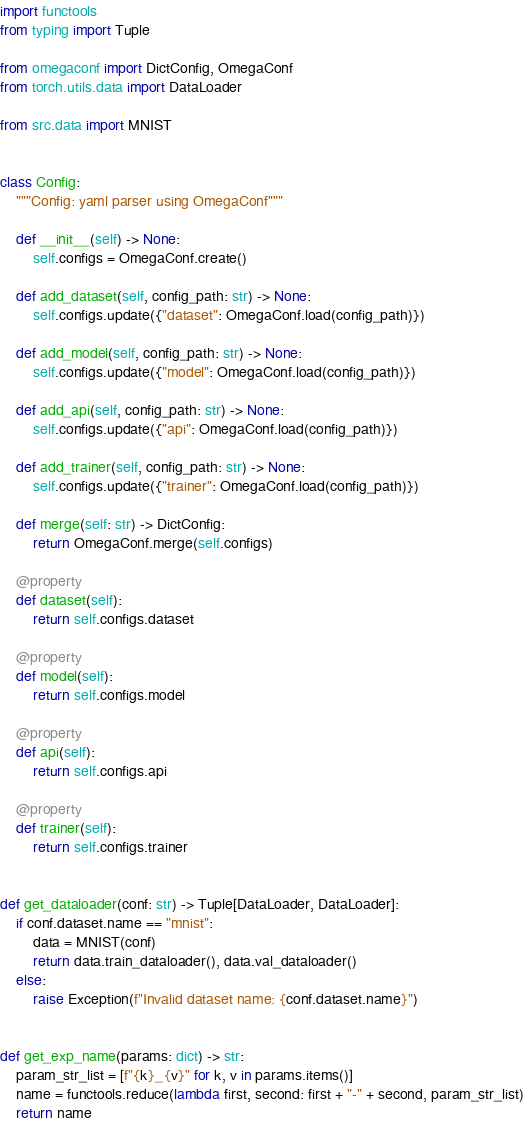Convert code to text. <code><loc_0><loc_0><loc_500><loc_500><_Python_>import functools
from typing import Tuple

from omegaconf import DictConfig, OmegaConf
from torch.utils.data import DataLoader

from src.data import MNIST


class Config:
    """Config: yaml parser using OmegaConf"""

    def __init__(self) -> None:
        self.configs = OmegaConf.create()

    def add_dataset(self, config_path: str) -> None:
        self.configs.update({"dataset": OmegaConf.load(config_path)})

    def add_model(self, config_path: str) -> None:
        self.configs.update({"model": OmegaConf.load(config_path)})

    def add_api(self, config_path: str) -> None:
        self.configs.update({"api": OmegaConf.load(config_path)})

    def add_trainer(self, config_path: str) -> None:
        self.configs.update({"trainer": OmegaConf.load(config_path)})

    def merge(self: str) -> DictConfig:
        return OmegaConf.merge(self.configs)

    @property
    def dataset(self):
        return self.configs.dataset

    @property
    def model(self):
        return self.configs.model

    @property
    def api(self):
        return self.configs.api

    @property
    def trainer(self):
        return self.configs.trainer


def get_dataloader(conf: str) -> Tuple[DataLoader, DataLoader]:
    if conf.dataset.name == "mnist":
        data = MNIST(conf)
        return data.train_dataloader(), data.val_dataloader()
    else:
        raise Exception(f"Invalid dataset name: {conf.dataset.name}")


def get_exp_name(params: dict) -> str:
    param_str_list = [f"{k}_{v}" for k, v in params.items()]
    name = functools.reduce(lambda first, second: first + "-" + second, param_str_list)
    return name
</code> 